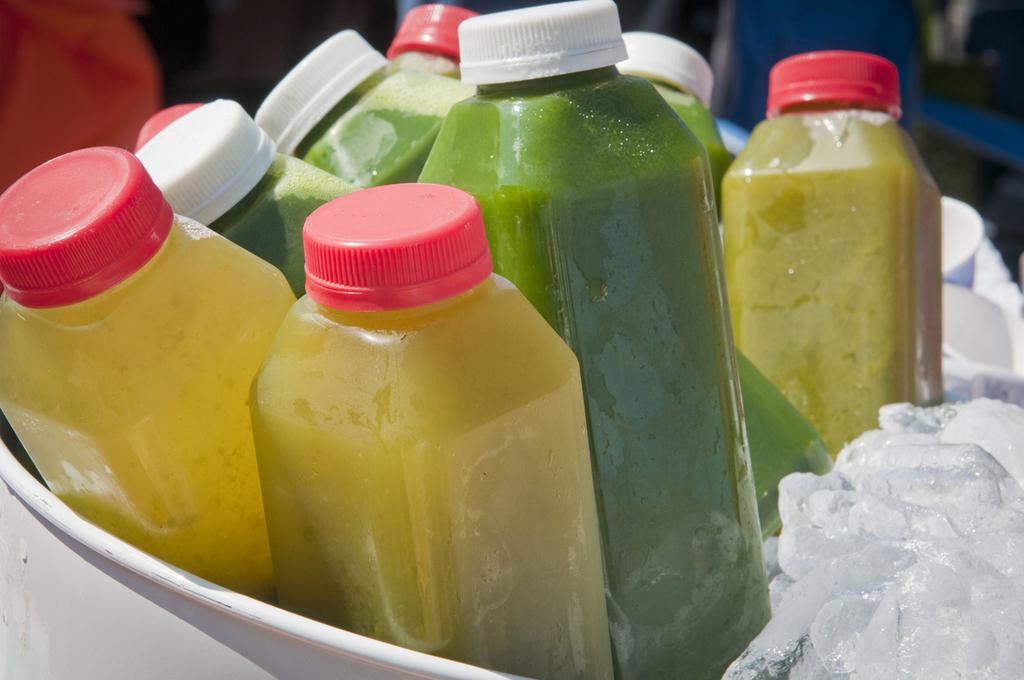What is the main subject of the image? The main subject of the image is a group of bottles. What is inside the bottles? The bottles are filled with a drink. What is placed beside the bottles? There is ice beside the bottles. Can you see a robin building a nest on top of the bottles in the image? No, there is no robin or nest present in the image. 